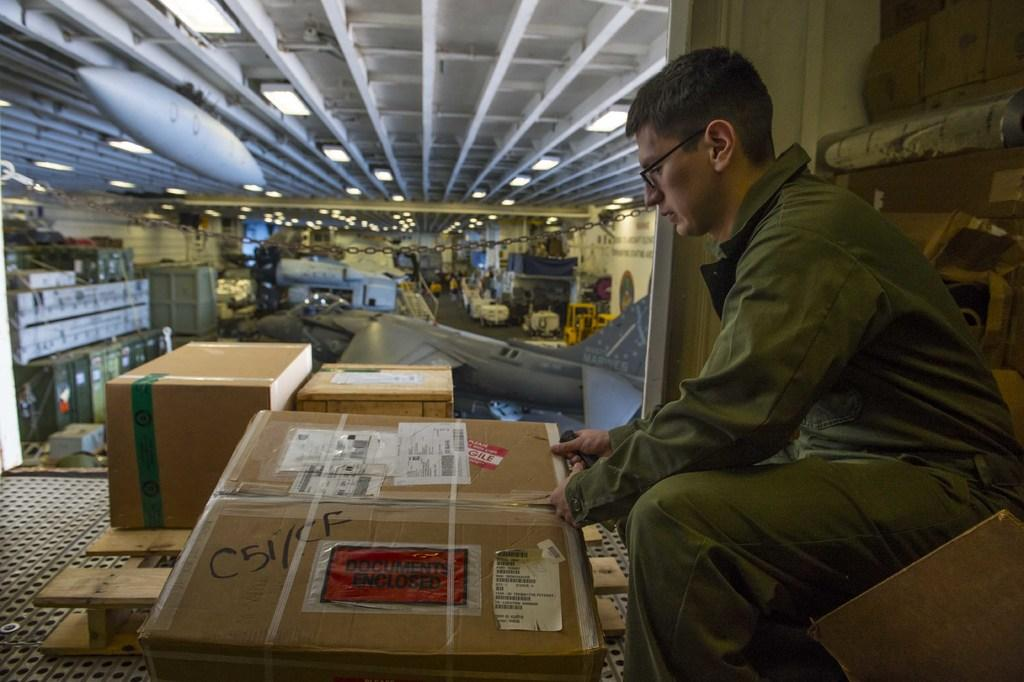<image>
Give a short and clear explanation of the subsequent image. A large cardboard box with a Documents Enclosed pouch stuck to it is being checked by a worker. 